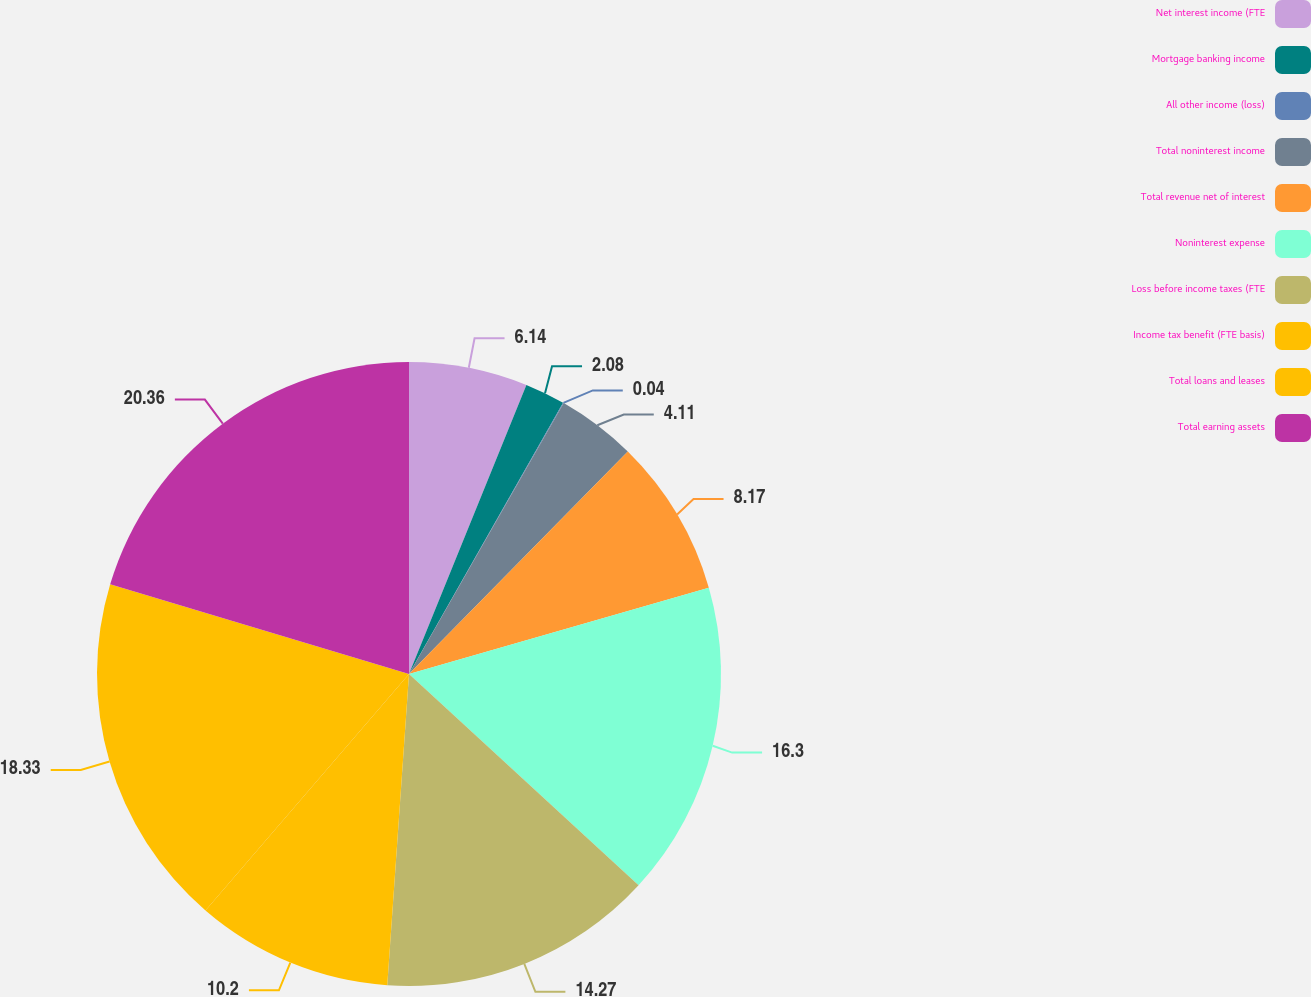Convert chart. <chart><loc_0><loc_0><loc_500><loc_500><pie_chart><fcel>Net interest income (FTE<fcel>Mortgage banking income<fcel>All other income (loss)<fcel>Total noninterest income<fcel>Total revenue net of interest<fcel>Noninterest expense<fcel>Loss before income taxes (FTE<fcel>Income tax benefit (FTE basis)<fcel>Total loans and leases<fcel>Total earning assets<nl><fcel>6.14%<fcel>2.08%<fcel>0.04%<fcel>4.11%<fcel>8.17%<fcel>16.3%<fcel>14.27%<fcel>10.2%<fcel>18.33%<fcel>20.36%<nl></chart> 